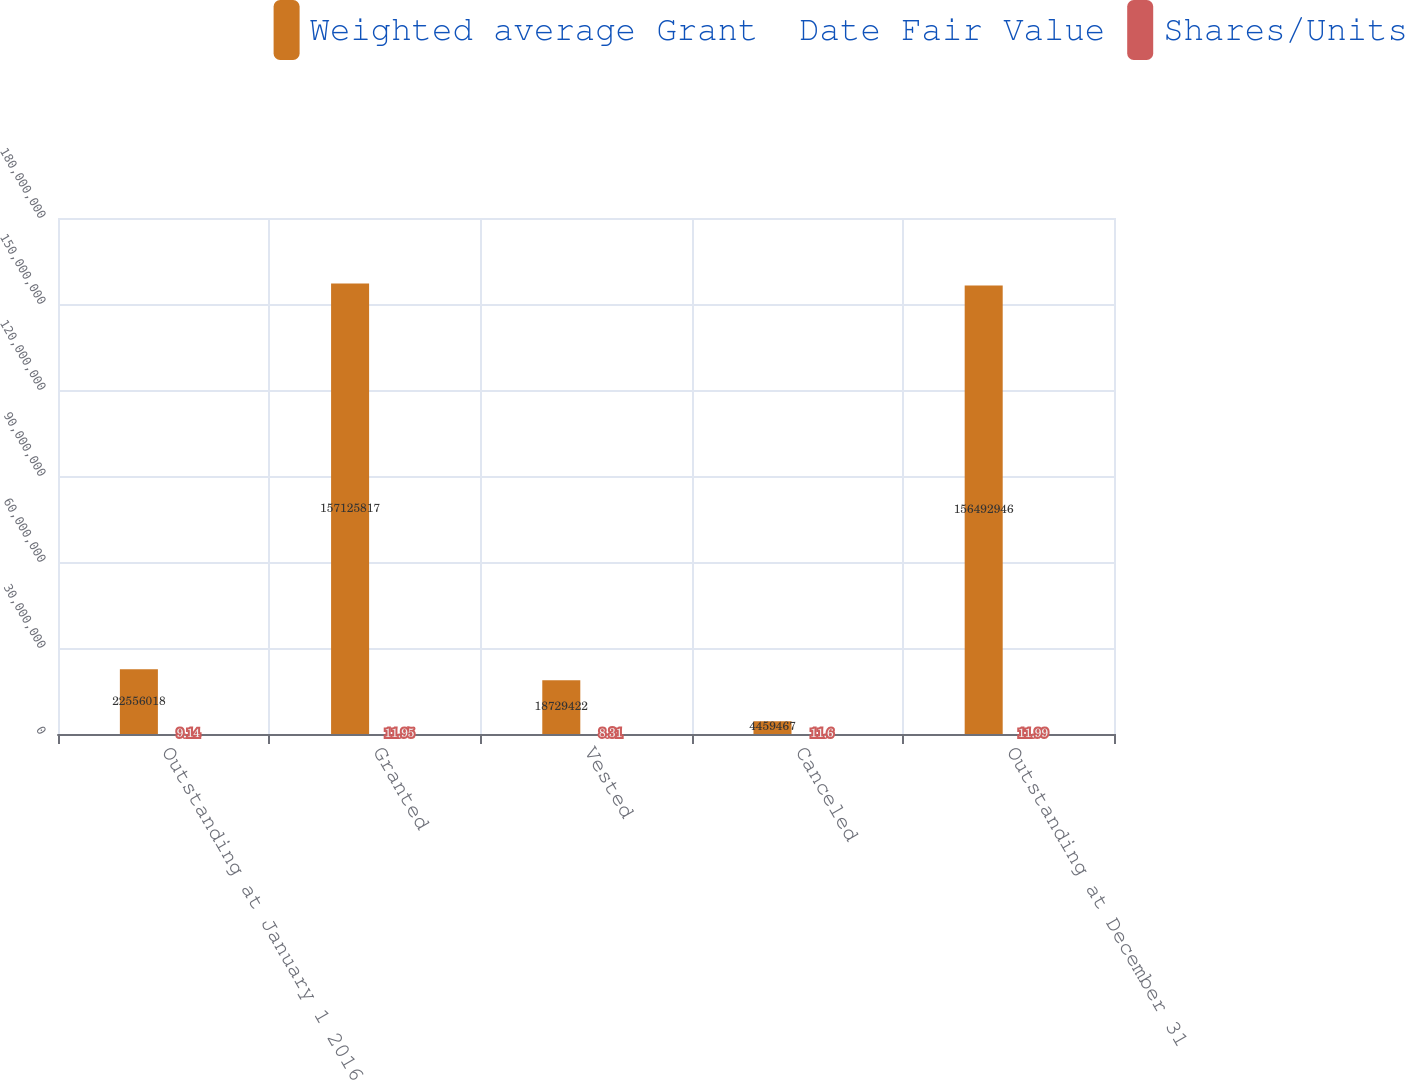<chart> <loc_0><loc_0><loc_500><loc_500><stacked_bar_chart><ecel><fcel>Outstanding at January 1 2016<fcel>Granted<fcel>Vested<fcel>Canceled<fcel>Outstanding at December 31<nl><fcel>Weighted average Grant  Date Fair Value<fcel>2.2556e+07<fcel>1.57126e+08<fcel>1.87294e+07<fcel>4.45947e+06<fcel>1.56493e+08<nl><fcel>Shares/Units<fcel>9.14<fcel>11.95<fcel>8.31<fcel>11.6<fcel>11.99<nl></chart> 